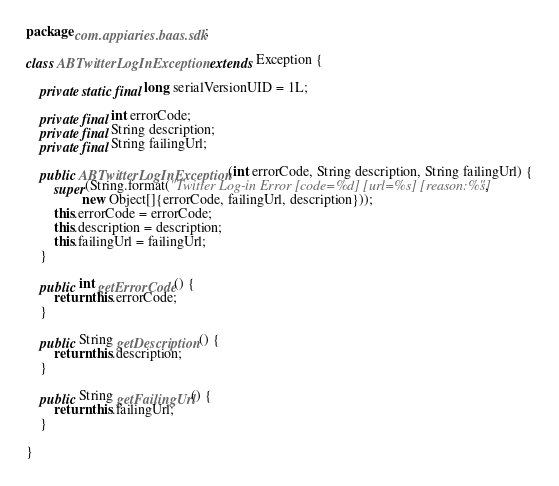Convert code to text. <code><loc_0><loc_0><loc_500><loc_500><_Java_>package com.appiaries.baas.sdk;

class ABTwitterLogInException extends Exception {

    private static final long serialVersionUID = 1L;

    private final int errorCode;
    private final String description;
    private final String failingUrl;

    public ABTwitterLogInException(int errorCode, String description, String failingUrl) {
        super(String.format("Twitter Log-in Error [code=%d] [url=%s] [reason:%s]",
                new Object[]{errorCode, failingUrl, description}));
        this.errorCode = errorCode;
        this.description = description;
        this.failingUrl = failingUrl;
    }

    public int getErrorCode() {
        return this.errorCode;
    }

    public String getDescription() {
        return this.description;
    }

    public String getFailingUrl() {
        return this.failingUrl;
    }

}
</code> 